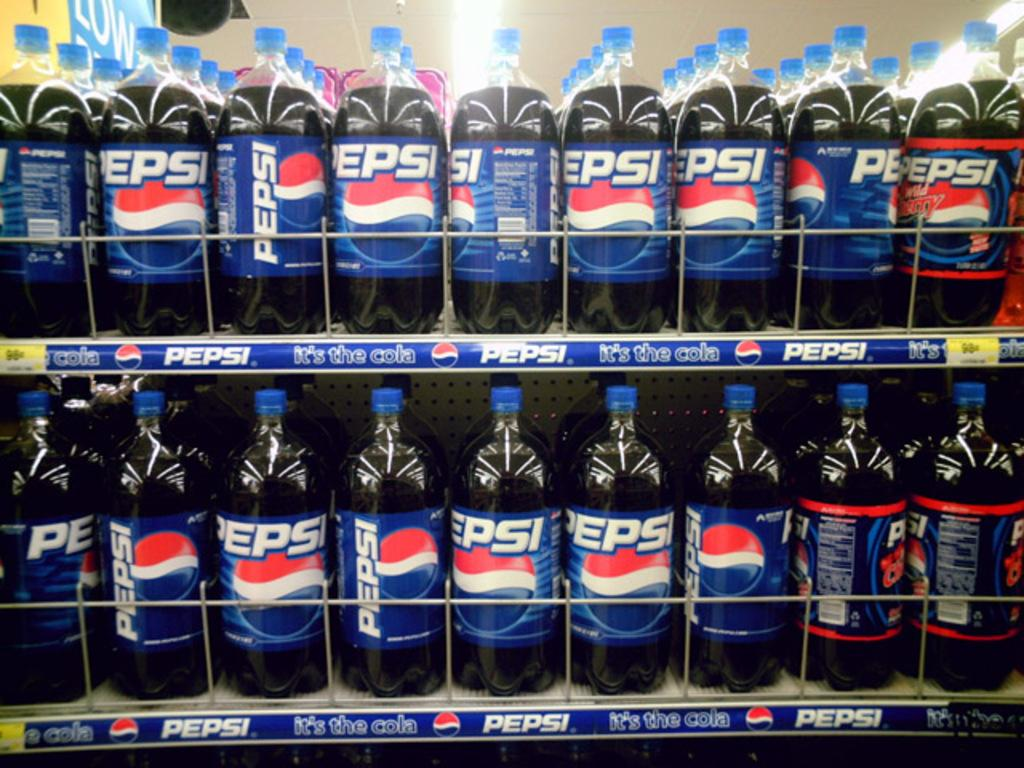<image>
Describe the image concisely. a super market isle full of pepsi products on both top and bottom. 